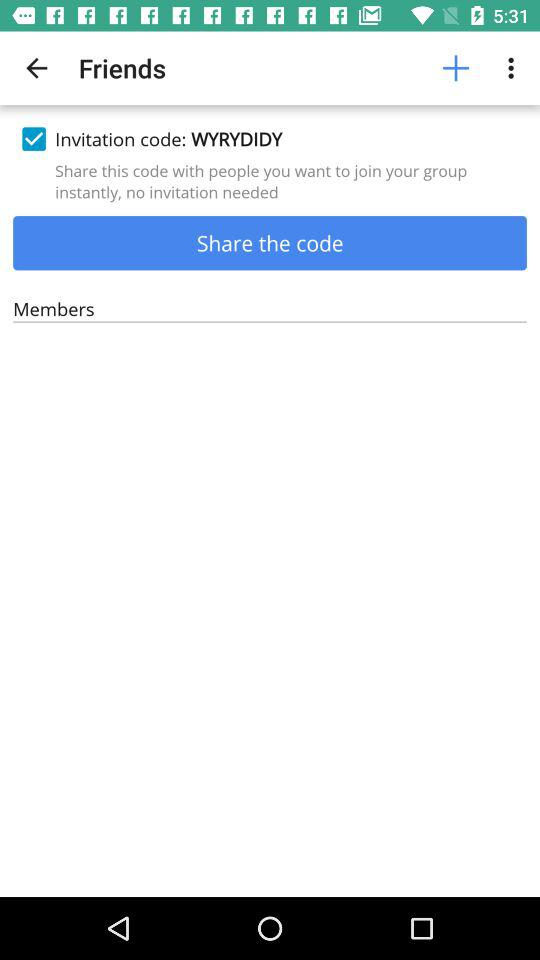What option is checked marked? The option is "Invitation code: WYRYDIDY". 